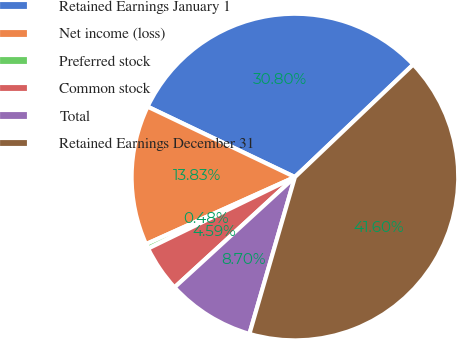<chart> <loc_0><loc_0><loc_500><loc_500><pie_chart><fcel>Retained Earnings January 1<fcel>Net income (loss)<fcel>Preferred stock<fcel>Common stock<fcel>Total<fcel>Retained Earnings December 31<nl><fcel>30.8%<fcel>13.83%<fcel>0.48%<fcel>4.59%<fcel>8.7%<fcel>41.6%<nl></chart> 